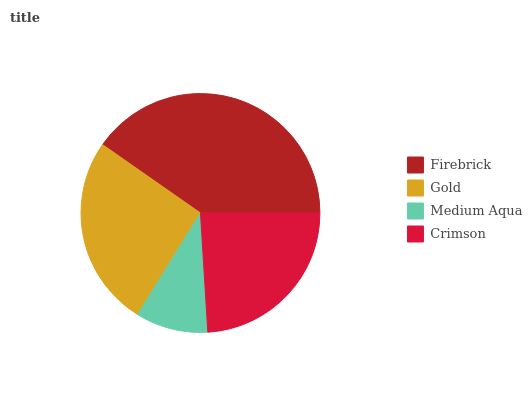Is Medium Aqua the minimum?
Answer yes or no. Yes. Is Firebrick the maximum?
Answer yes or no. Yes. Is Gold the minimum?
Answer yes or no. No. Is Gold the maximum?
Answer yes or no. No. Is Firebrick greater than Gold?
Answer yes or no. Yes. Is Gold less than Firebrick?
Answer yes or no. Yes. Is Gold greater than Firebrick?
Answer yes or no. No. Is Firebrick less than Gold?
Answer yes or no. No. Is Gold the high median?
Answer yes or no. Yes. Is Crimson the low median?
Answer yes or no. Yes. Is Medium Aqua the high median?
Answer yes or no. No. Is Medium Aqua the low median?
Answer yes or no. No. 